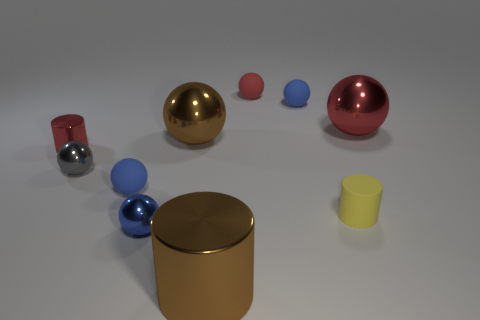Do the large red metallic object and the small red matte thing have the same shape? Yes, the large red metallic object and the small red matte thing do have the same spherical shape, despite differences in size and surface texture. 